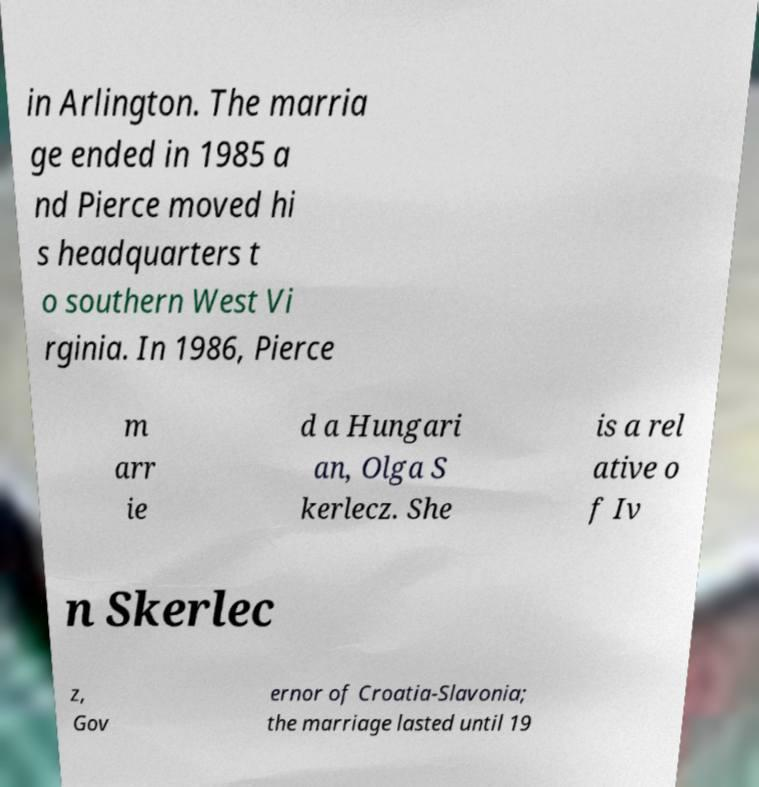Can you read and provide the text displayed in the image?This photo seems to have some interesting text. Can you extract and type it out for me? in Arlington. The marria ge ended in 1985 a nd Pierce moved hi s headquarters t o southern West Vi rginia. In 1986, Pierce m arr ie d a Hungari an, Olga S kerlecz. She is a rel ative o f Iv n Skerlec z, Gov ernor of Croatia-Slavonia; the marriage lasted until 19 